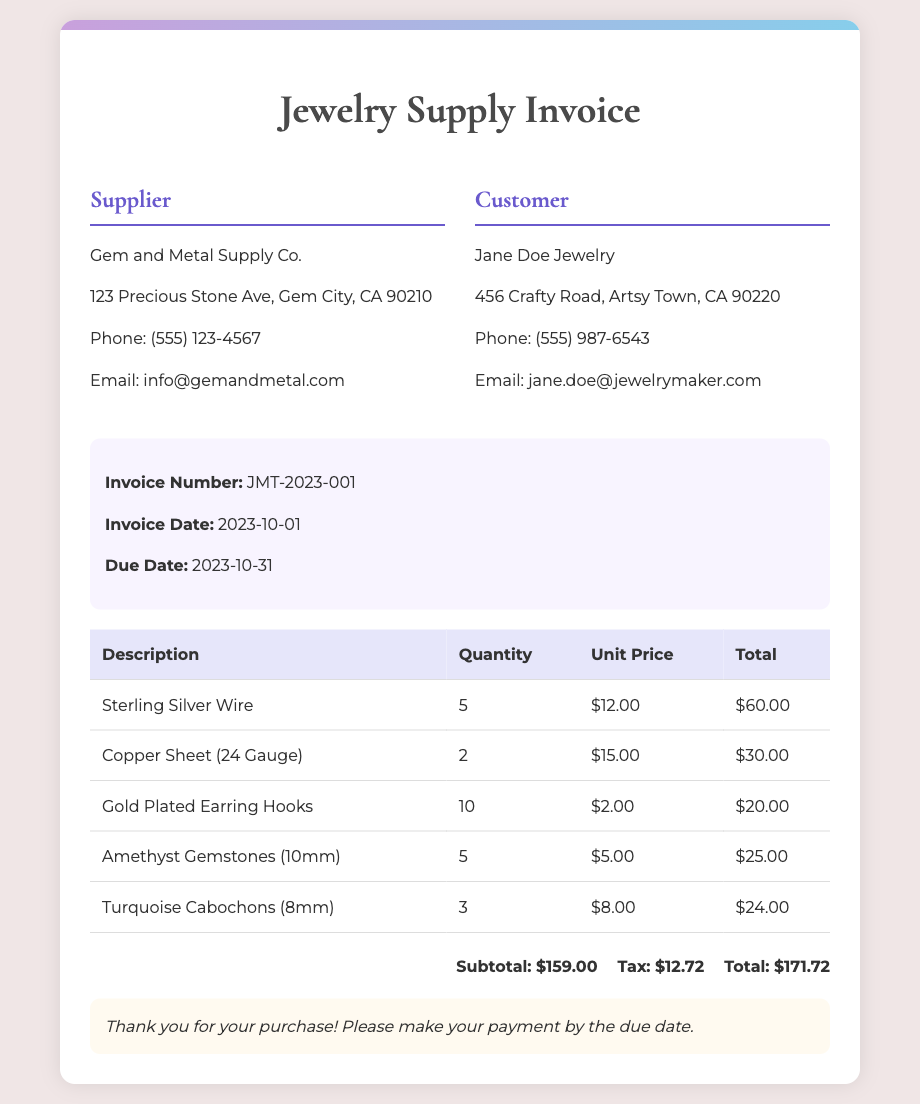What is the invoice number? The invoice number is provided in the document as a unique identifier for the purchase.
Answer: JMT-2023-001 Who is the supplier? The supplier's details are listed in the invoice, including their company name.
Answer: Gem and Metal Supply Co What is the purchase date? The document specifies the date when the invoice was created, which is important for payment terms.
Answer: 2023-10-01 How many Sterling Silver Wires were purchased? The quantity of each item is listed in the table of the invoice for inventory reference.
Answer: 5 What is the subtotal amount? The subtotal is calculated before tax and is listed in the summary section of the invoice.
Answer: $159.00 What is the total amount due? The total amount due includes both the subtotal and tax, which is crucial for payment purposes.
Answer: $171.72 What type of gemstones were purchased? The document lists specific types of gemstones included in the purchase order.
Answer: Amethyst Gemstones (10mm) What is the tax amount? The tax is calculated on the subtotal and is provided in the summary to indicate the additional cost.
Answer: $12.72 When is the due date for payment? The due date for payment is mentioned in the document to ensure timely payment by the customer.
Answer: 2023-10-31 